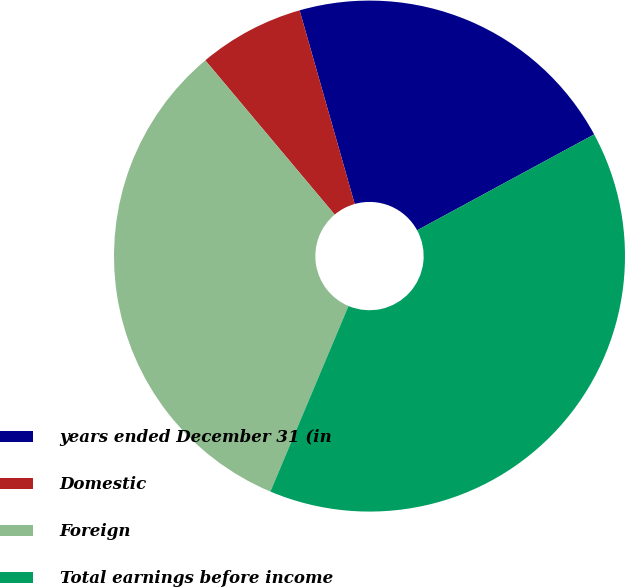Convert chart. <chart><loc_0><loc_0><loc_500><loc_500><pie_chart><fcel>years ended December 31 (in<fcel>Domestic<fcel>Foreign<fcel>Total earnings before income<nl><fcel>21.51%<fcel>6.7%<fcel>32.55%<fcel>39.24%<nl></chart> 